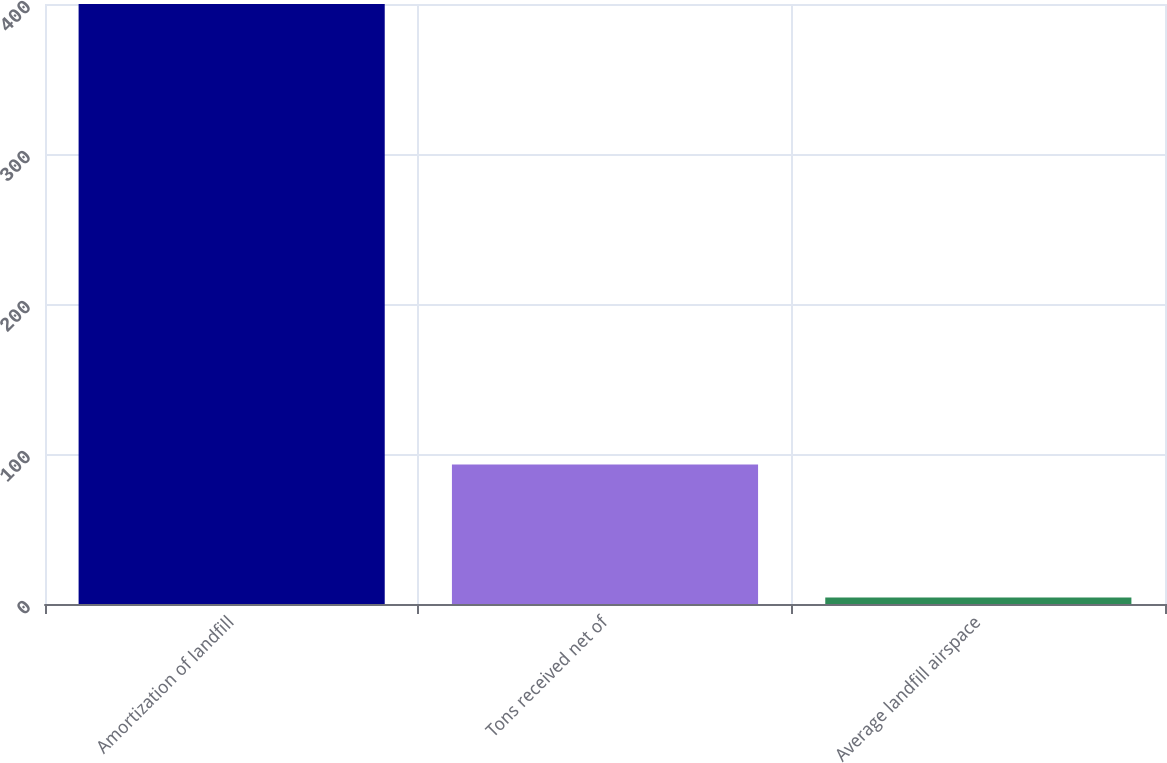<chart> <loc_0><loc_0><loc_500><loc_500><bar_chart><fcel>Amortization of landfill<fcel>Tons received net of<fcel>Average landfill airspace<nl><fcel>400<fcel>93<fcel>4.29<nl></chart> 